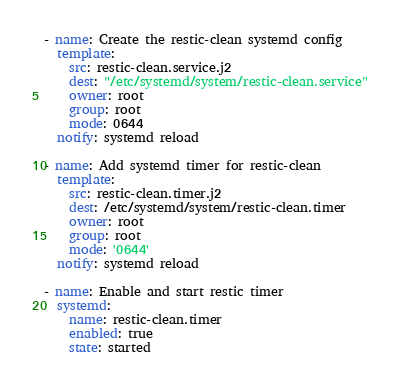Convert code to text. <code><loc_0><loc_0><loc_500><loc_500><_YAML_>- name: Create the restic-clean systemd config
  template:
    src: restic-clean.service.j2
    dest: "/etc/systemd/system/restic-clean.service"
    owner: root
    group: root
    mode: 0644
  notify: systemd reload

- name: Add systemd timer for restic-clean
  template:
    src: restic-clean.timer.j2
    dest: /etc/systemd/system/restic-clean.timer
    owner: root
    group: root
    mode: '0644'
  notify: systemd reload

- name: Enable and start restic timer
  systemd:
    name: restic-clean.timer
    enabled: true
    state: started
</code> 